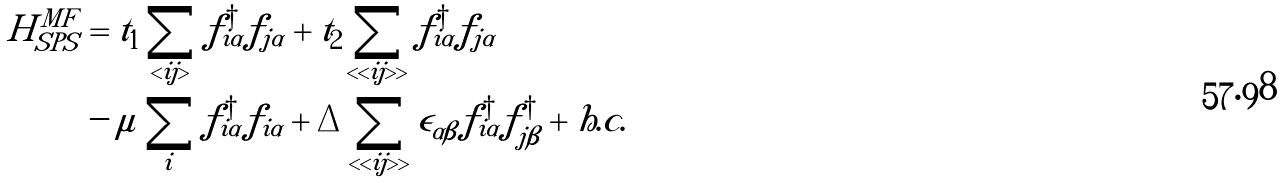<formula> <loc_0><loc_0><loc_500><loc_500>H ^ { M F } _ { S P S } & = t _ { 1 } \sum _ { < i j > } f _ { i \alpha } ^ { \dagger } f _ { j \alpha } + t _ { 2 } \sum _ { < < i j > > } f _ { i \alpha } ^ { \dagger } f _ { j \alpha } \\ & - \mu \sum _ { i } f _ { i \alpha } ^ { \dagger } f _ { i \alpha } + \Delta \sum _ { < < i j > > } \epsilon _ { \alpha \beta } f _ { i \alpha } ^ { \dagger } f _ { j \beta } ^ { \dagger } + h . c .</formula> 